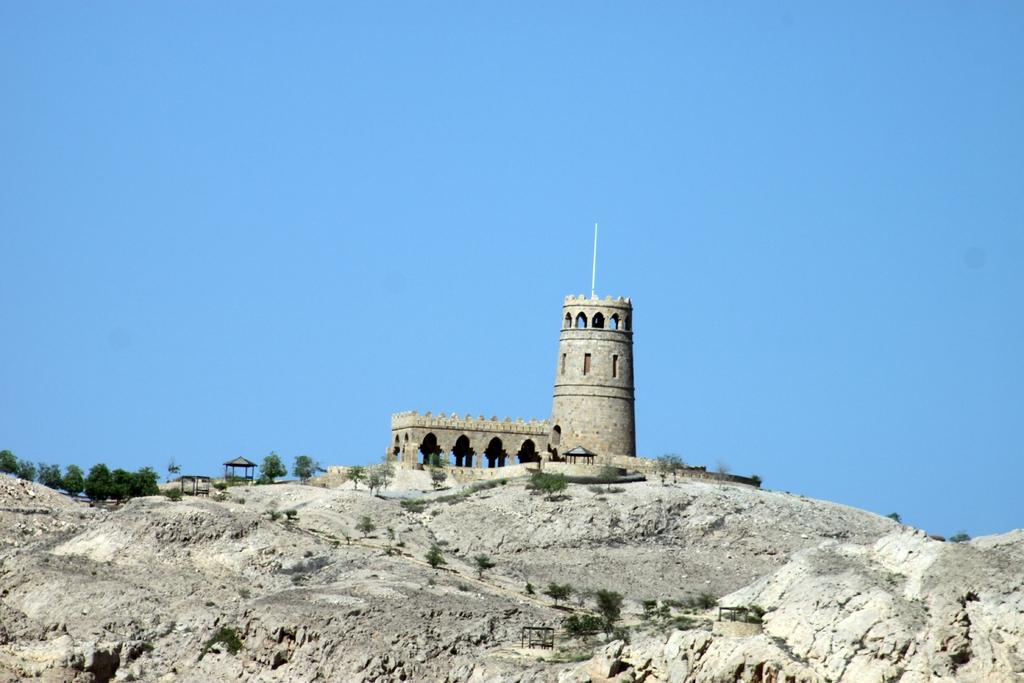What type of natural elements can be seen in the image? There are rocks, a body of water, and trees visible in the image. What is the color of the sky in the background of the image? The sky is blue in the background of the image. What book is the actor reading while sitting on the rocks in the image? There is no actor or book present in the image; it features natural elements such as rocks, water, and trees. 